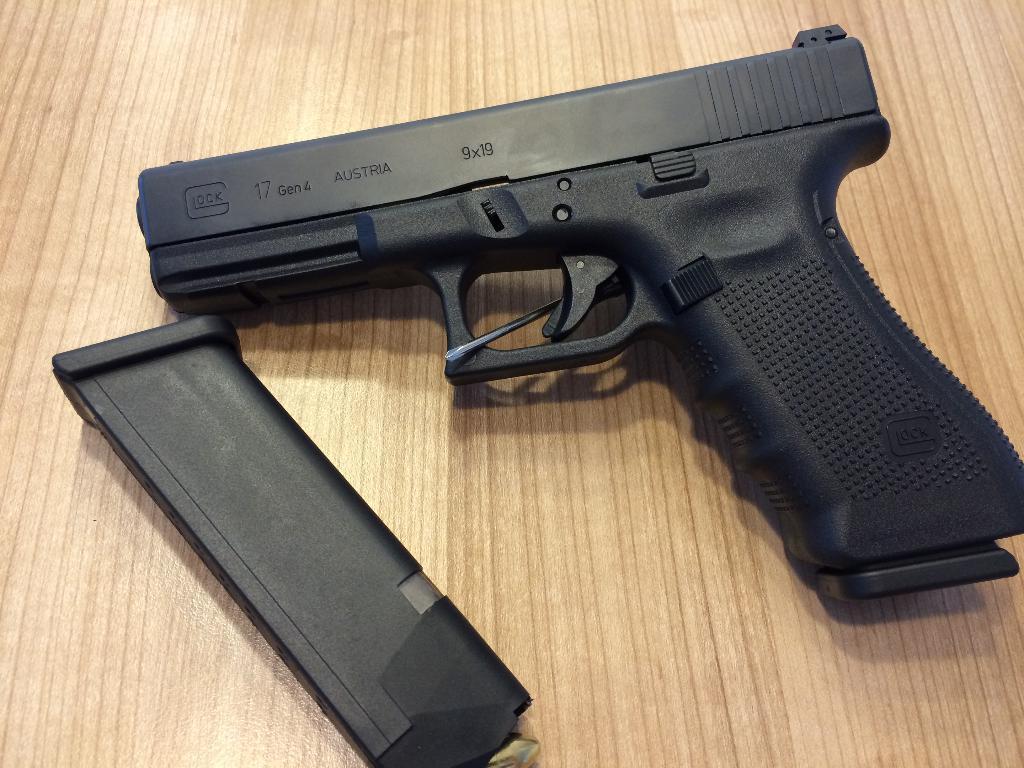Can you describe this image briefly? In this image there is a black color gun and a black color magazine on the wooden board. 